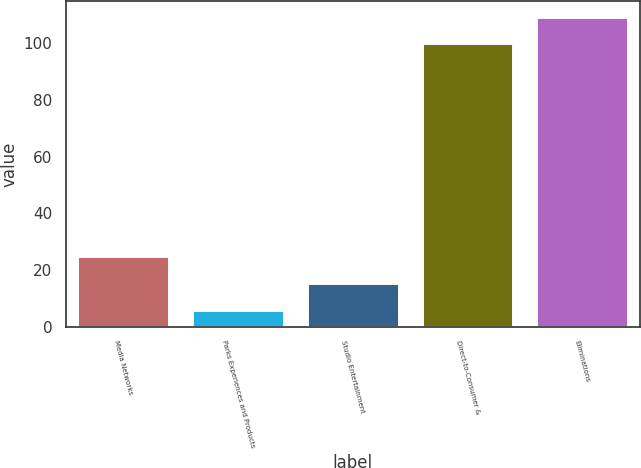<chart> <loc_0><loc_0><loc_500><loc_500><bar_chart><fcel>Media Networks<fcel>Parks Experiences and Products<fcel>Studio Entertainment<fcel>Direct-to-Consumer &<fcel>Eliminations<nl><fcel>24.8<fcel>6<fcel>15.4<fcel>100<fcel>109.4<nl></chart> 